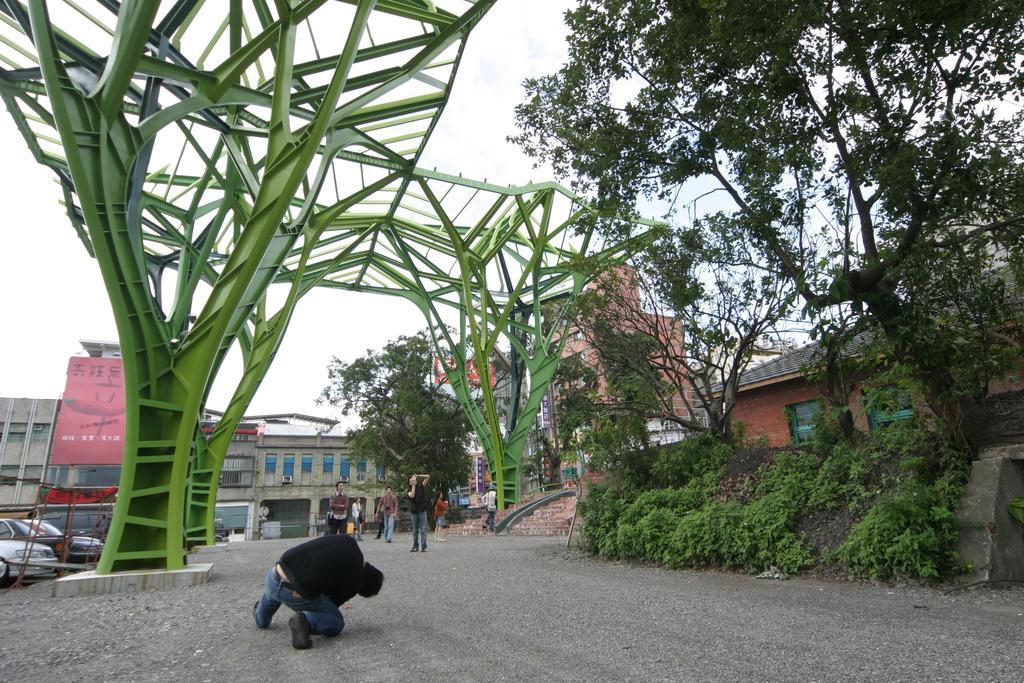Describe this image in one or two sentences. In this image we can see people. On the right there are trees. On the left we can see an arch. In the background there are buildings and there are cars. At the top there is sky. 